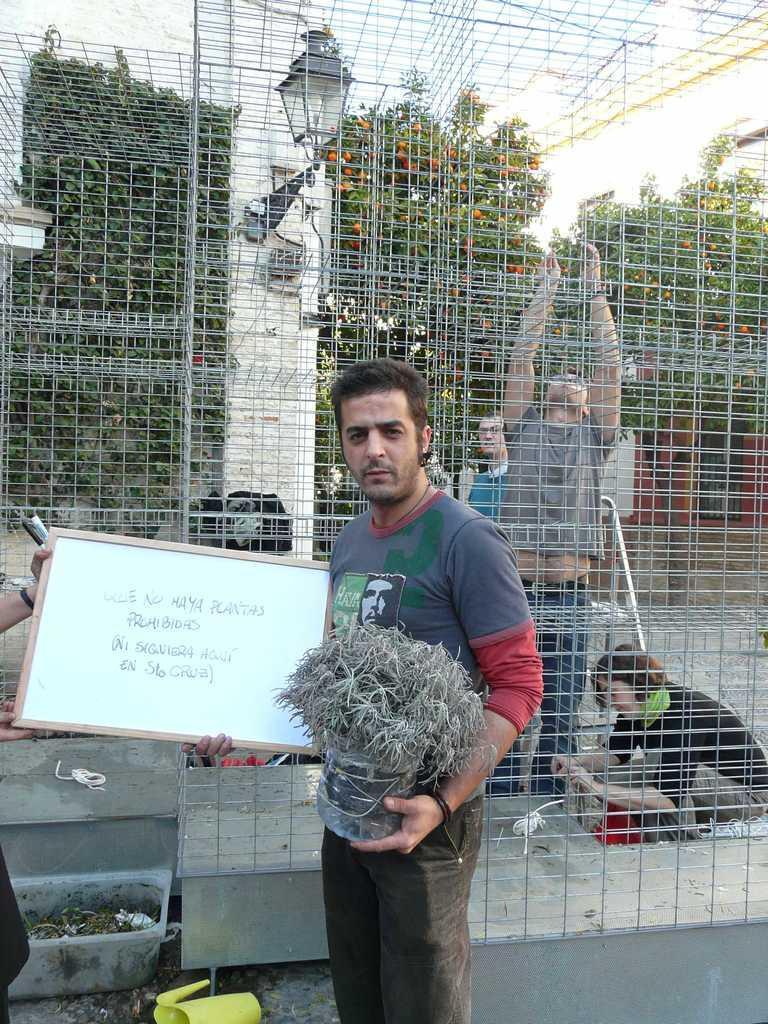Could you give a brief overview of what you see in this image? The man in front of the picture is holding a flower pot in one of his hands and in the other hand he is holding a white board with some text written on it. Behind him, we see a fence. We see people are standing and the woman in black T-shirt is sitting on the floor. On the left side, we see a plastic tub and a mug in yellow color. There are trees in the background. 